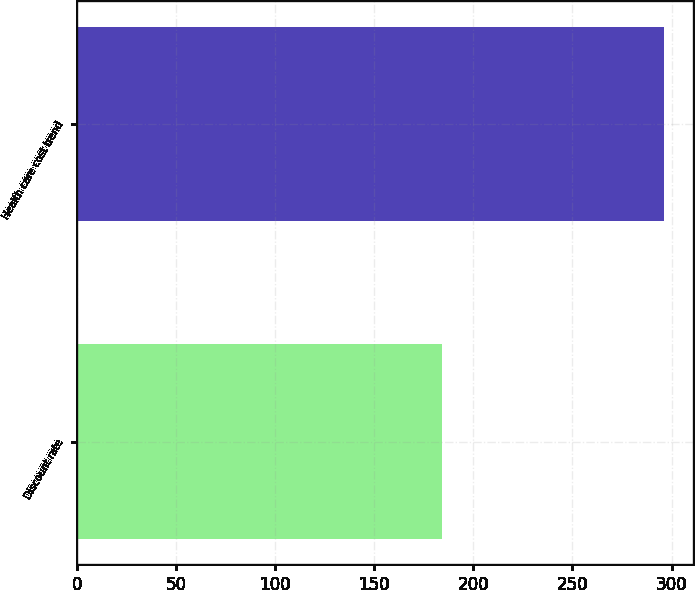Convert chart. <chart><loc_0><loc_0><loc_500><loc_500><bar_chart><fcel>Discount rate<fcel>Health care cost trend<nl><fcel>184<fcel>296<nl></chart> 